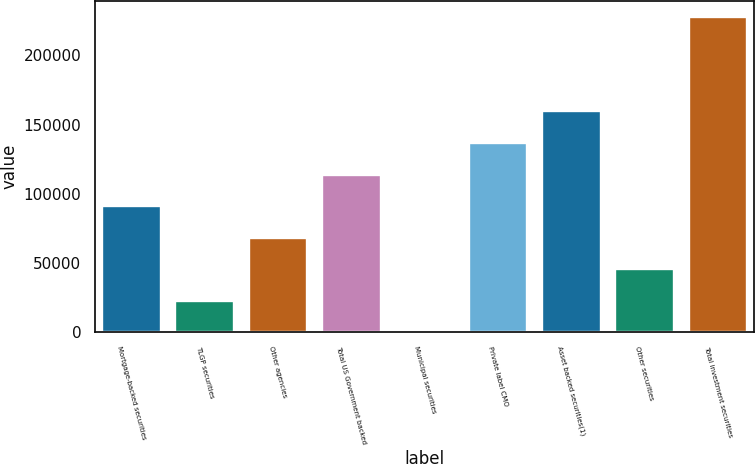<chart> <loc_0><loc_0><loc_500><loc_500><bar_chart><fcel>Mortgage-backed securities<fcel>TLGP securities<fcel>Other agencies<fcel>Total US Government backed<fcel>Municipal securities<fcel>Private label CMO<fcel>Asset backed securities(1)<fcel>Other securities<fcel>Total investment securities<nl><fcel>91219.6<fcel>22869.4<fcel>68436.2<fcel>114003<fcel>86<fcel>136786<fcel>159570<fcel>45652.8<fcel>227920<nl></chart> 